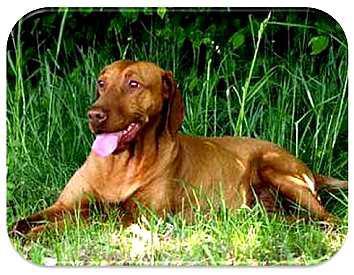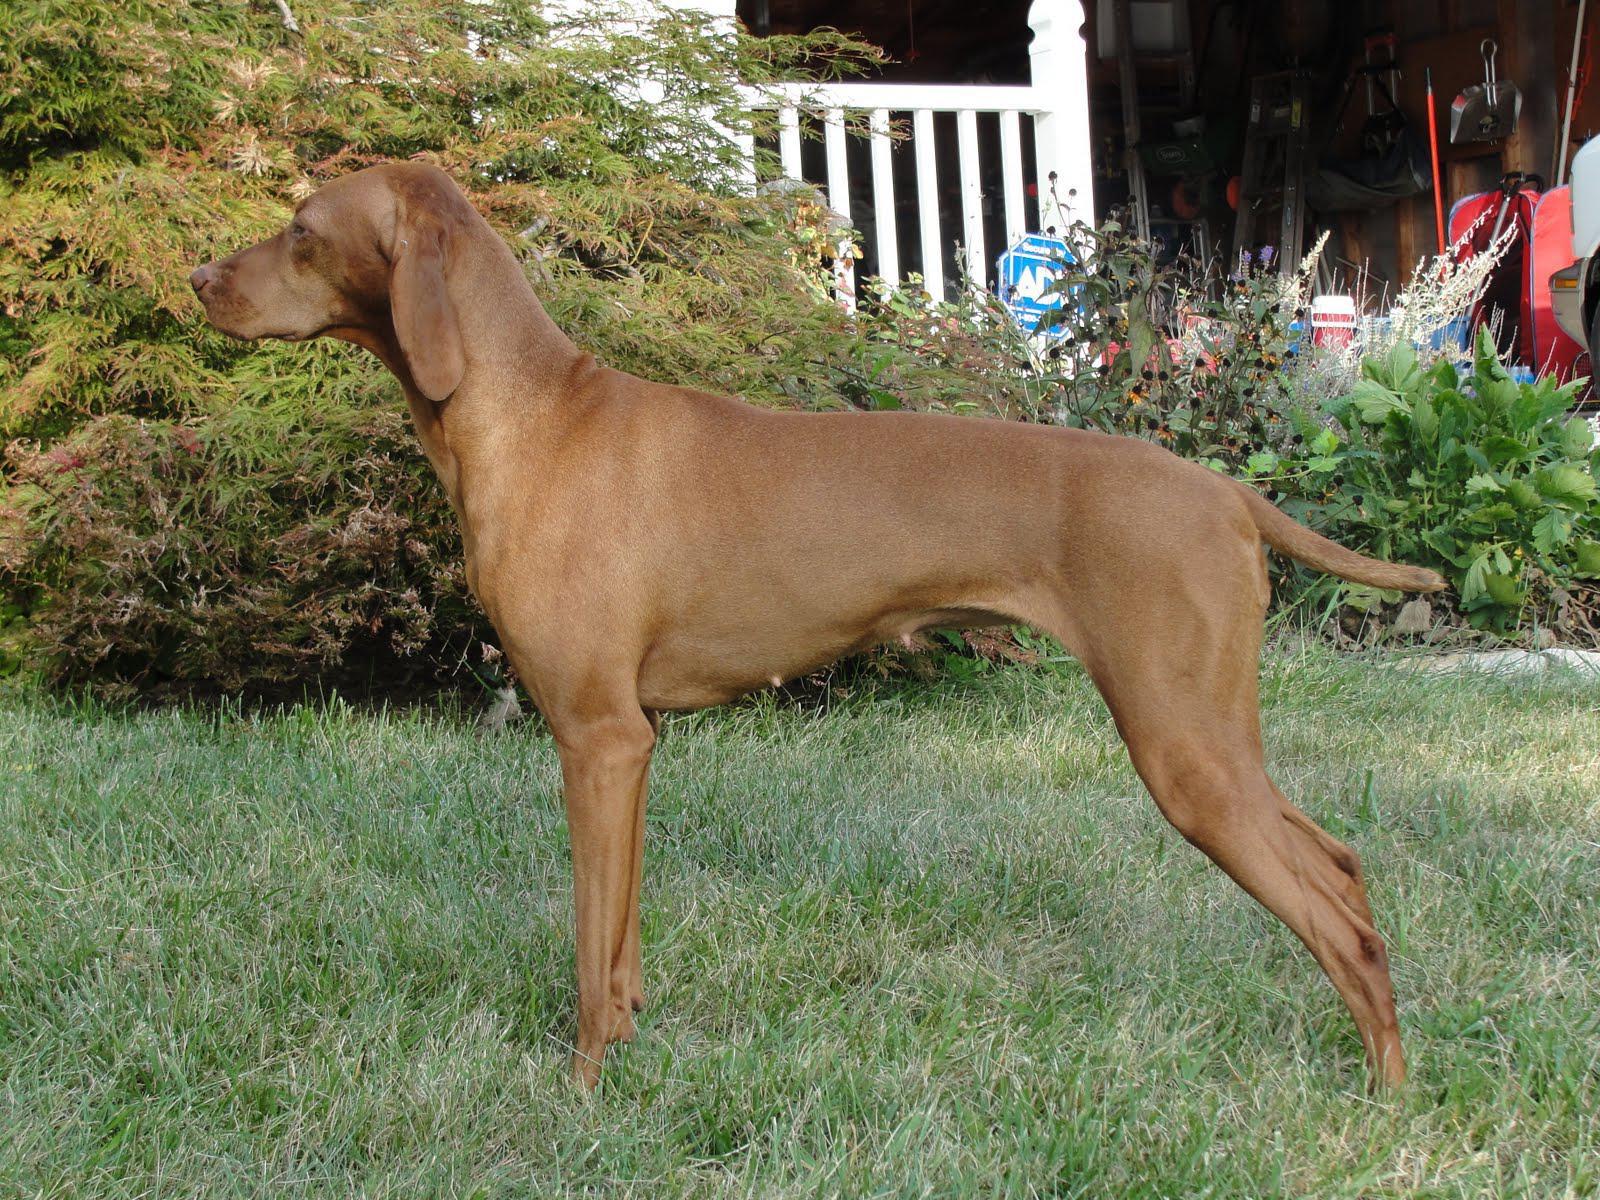The first image is the image on the left, the second image is the image on the right. Evaluate the accuracy of this statement regarding the images: "A total of three red-orange dogs, all wearing collars, are shown - and the right image contains two side-by-side dogs gazing in the same direction.". Is it true? Answer yes or no. No. The first image is the image on the left, the second image is the image on the right. Assess this claim about the two images: "One dog's teeth are visible.". Correct or not? Answer yes or no. Yes. 